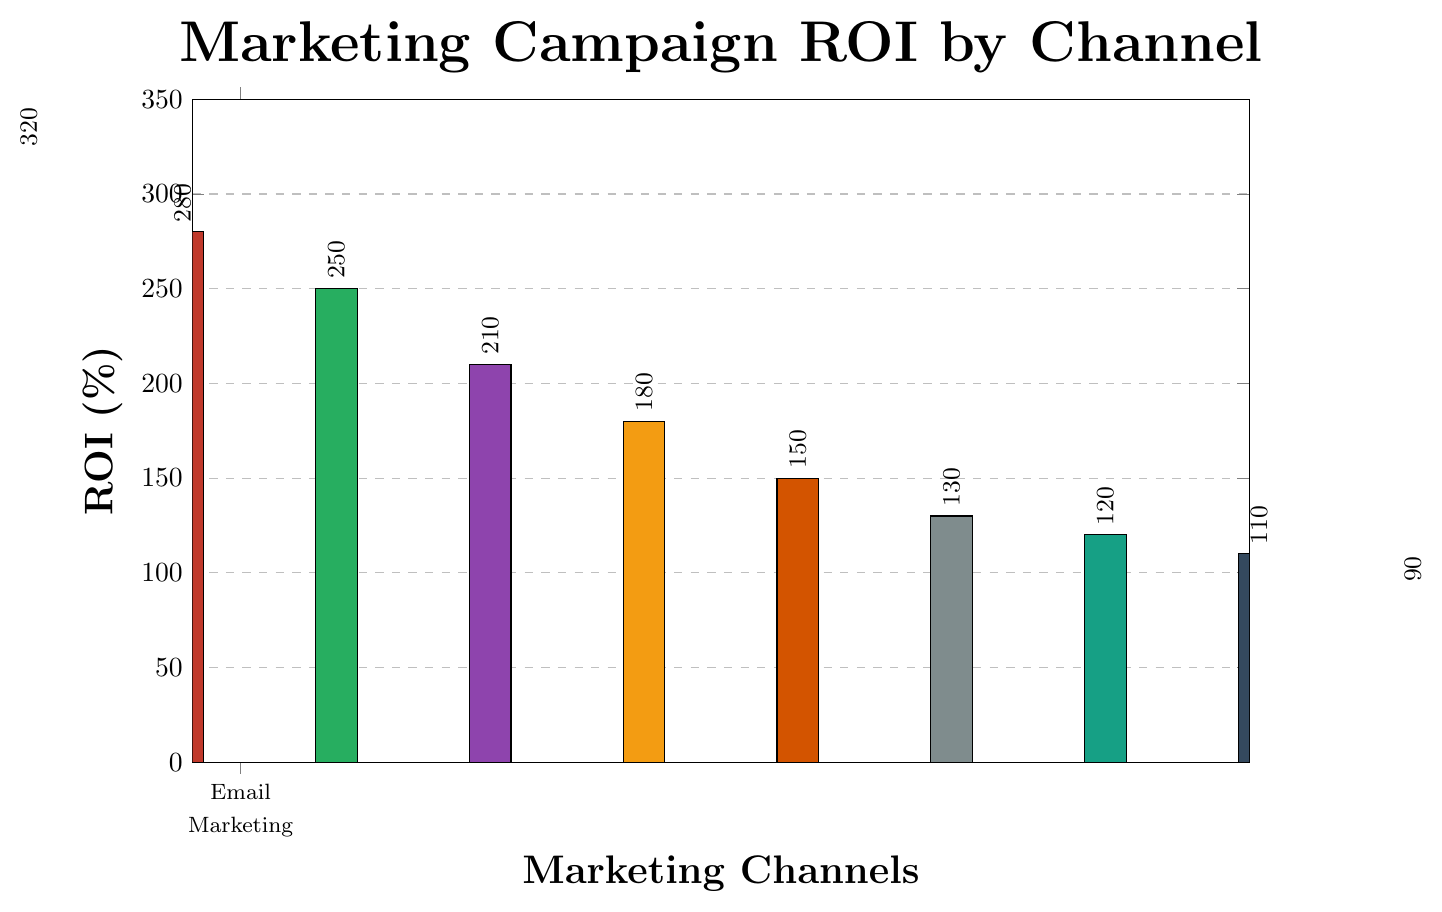Which marketing channel has the highest ROI? The bar corresponding to Email Marketing is the tallest, indicating it has the highest ROI.
Answer: Email Marketing Which marketing channel has the lowest ROI? The bar corresponding to PR Campaigns is the shortest, indicating it has the lowest ROI.
Answer: PR Campaigns How much higher is the ROI for Social Media Ads compared to Display Advertising? The ROI for Social Media Ads is 280%. The ROI for Display Advertising is 150%. The difference is 280% - 150% = 130%.
Answer: 130% Which channel has an ROI between 200% and 300%? The bars for Content Marketing (210%), Search Engine Marketing (250%), and Social Media Ads (280%) fall within the range of 200%-300%.
Answer: Content Marketing, Search Engine Marketing, Social Media Ads What is the total ROI for Email Marketing and Social Media Ads combined? The ROI for Email Marketing is 320% and for Social Media Ads is 280%. The total combined ROI is 320% + 280% = 600%.
Answer: 600% Is the ROI for Search Engine Marketing higher than for Affiliate Marketing? Search Engine Marketing has an ROI of 250%, while Affiliate Marketing has an ROI of 180%, so SEM's ROI is higher.
Answer: Yes How many channels have an ROI greater than 150%? Email Marketing (320%), Social Media Ads (280%), Search Engine Marketing (250%), Content Marketing (210%), and Affiliate Marketing (180%) all have ROIs greater than 150%. There are 5 such channels.
Answer: 5 Which marketing channel has an ROI closest to 100%? The ROI for Podcast Sponsorships is 110%, which is the closest to 100%.
Answer: Podcast Sponsorships Rank the channels from highest to lowest ROI. The ROIs in descending order are: Email Marketing (320%), Social Media Ads (280%), Search Engine Marketing (250%), Content Marketing (210%), Affiliate Marketing (180%), Display Advertising (150%), Influencer Partnerships (130%), Video Advertising (120%), Podcast Sponsorships (110%), PR Campaigns (90%).
Answer: Email Marketing, Social Media Ads, Search Engine Marketing, Content Marketing, Affiliate Marketing, Display Advertising, Influencer Partnerships, Video Advertising, Podcast Sponsorships, PR Campaigns Compare the ROI of Video Advertising and Podcast Sponsorships. Which one is higher? Video Advertising has an ROI of 120%, while Podcast Sponsorships have an ROI of 110%. Thus, Video Advertising has a higher ROI.
Answer: Video Advertising 